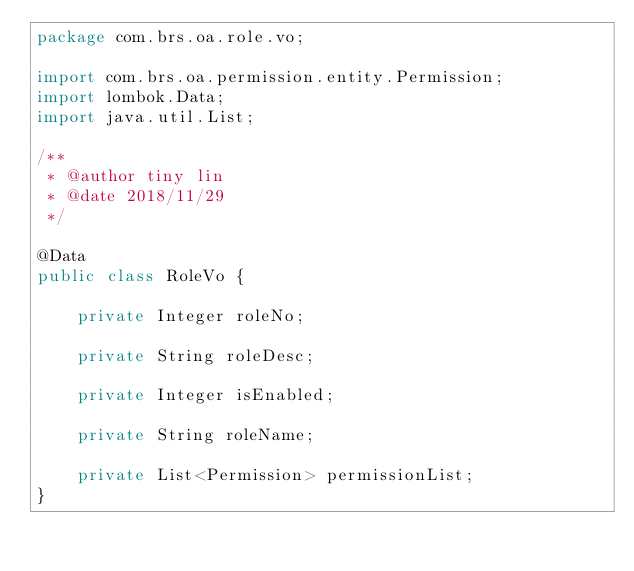<code> <loc_0><loc_0><loc_500><loc_500><_Java_>package com.brs.oa.role.vo;

import com.brs.oa.permission.entity.Permission;
import lombok.Data;
import java.util.List;

/**
 * @author tiny lin
 * @date 2018/11/29
 */

@Data
public class RoleVo {

    private Integer roleNo;

    private String roleDesc;

    private Integer isEnabled;

    private String roleName;

    private List<Permission> permissionList;
}
</code> 